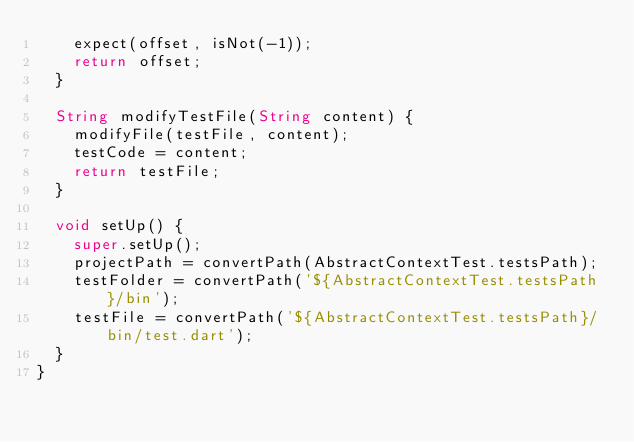<code> <loc_0><loc_0><loc_500><loc_500><_Dart_>    expect(offset, isNot(-1));
    return offset;
  }

  String modifyTestFile(String content) {
    modifyFile(testFile, content);
    testCode = content;
    return testFile;
  }

  void setUp() {
    super.setUp();
    projectPath = convertPath(AbstractContextTest.testsPath);
    testFolder = convertPath('${AbstractContextTest.testsPath}/bin');
    testFile = convertPath('${AbstractContextTest.testsPath}/bin/test.dart');
  }
}
</code> 